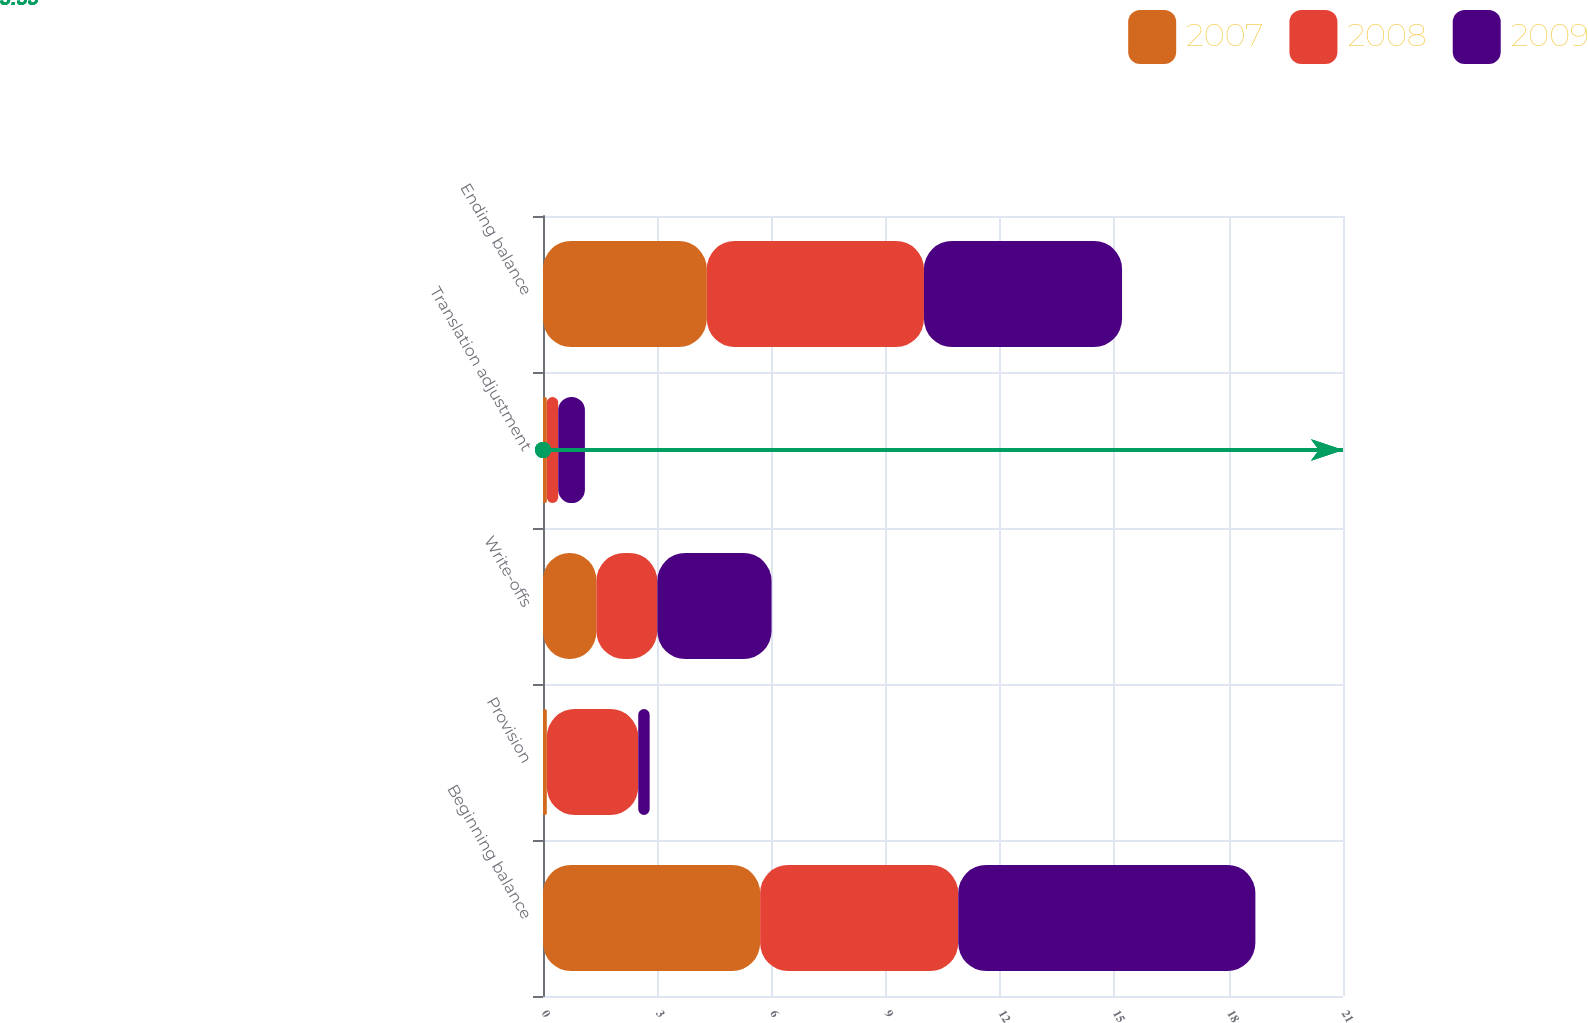Convert chart. <chart><loc_0><loc_0><loc_500><loc_500><stacked_bar_chart><ecel><fcel>Beginning balance<fcel>Provision<fcel>Write-offs<fcel>Translation adjustment<fcel>Ending balance<nl><fcel>2007<fcel>5.7<fcel>0.1<fcel>1.4<fcel>0.1<fcel>4.3<nl><fcel>2008<fcel>5.2<fcel>2.4<fcel>1.6<fcel>0.3<fcel>5.7<nl><fcel>2009<fcel>7.8<fcel>0.3<fcel>3<fcel>0.7<fcel>5.2<nl></chart> 